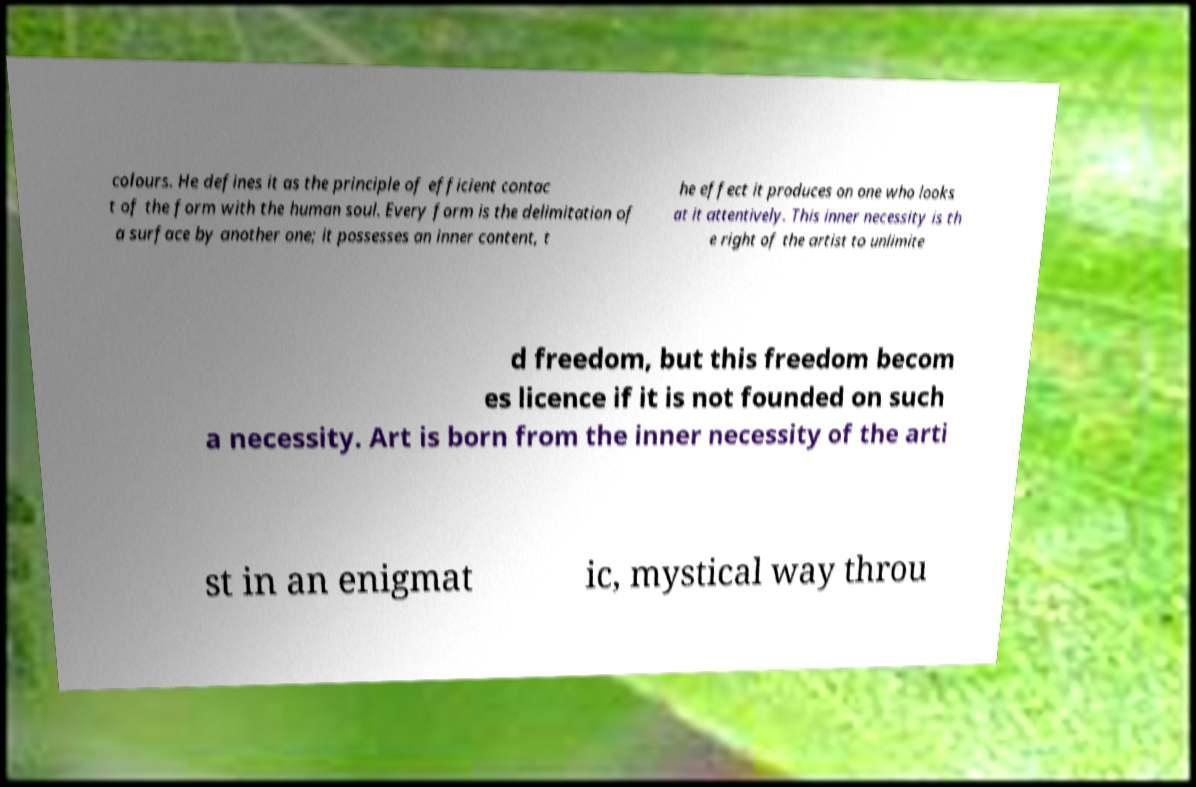Please read and relay the text visible in this image. What does it say? colours. He defines it as the principle of efficient contac t of the form with the human soul. Every form is the delimitation of a surface by another one; it possesses an inner content, t he effect it produces on one who looks at it attentively. This inner necessity is th e right of the artist to unlimite d freedom, but this freedom becom es licence if it is not founded on such a necessity. Art is born from the inner necessity of the arti st in an enigmat ic, mystical way throu 